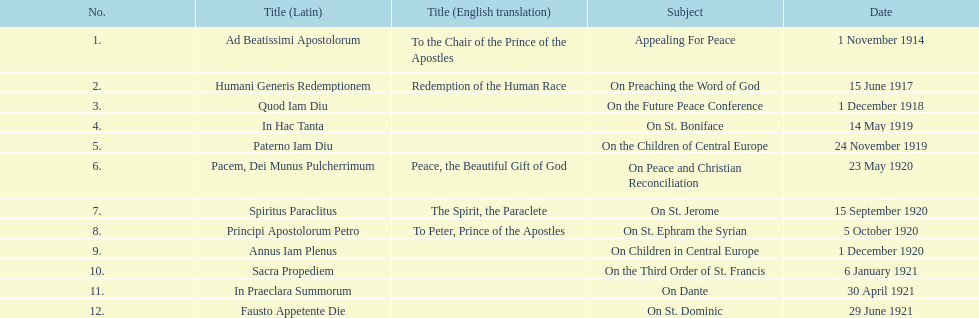Other than january how many encyclicals were in 1921? 2. 